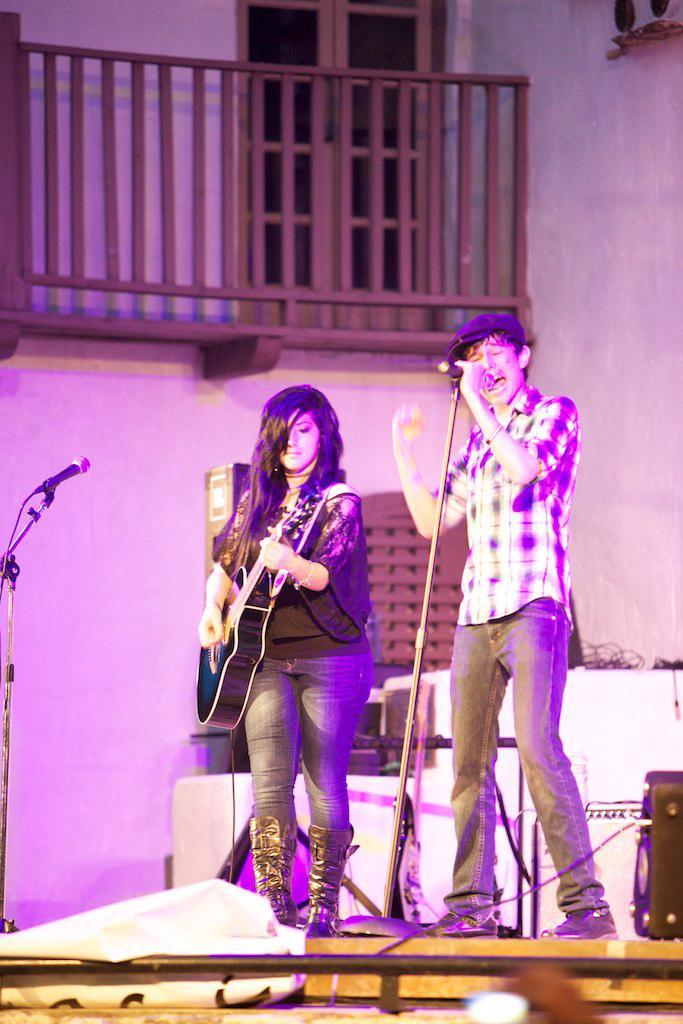How many people are in the image? There are two persons in the image. What are the two persons doing? One person is playing a guitar, and the other person is singing into a microphone. Can you describe the appearance of the person singing? The person singing is wearing a cap. What can be seen in the background of the image? There is a wall in the background of the image. What type of metal is the cast used for the person's broken arm in the image? There is no mention of a cast or a broken arm in the image; the two persons are engaged in musical activities. 